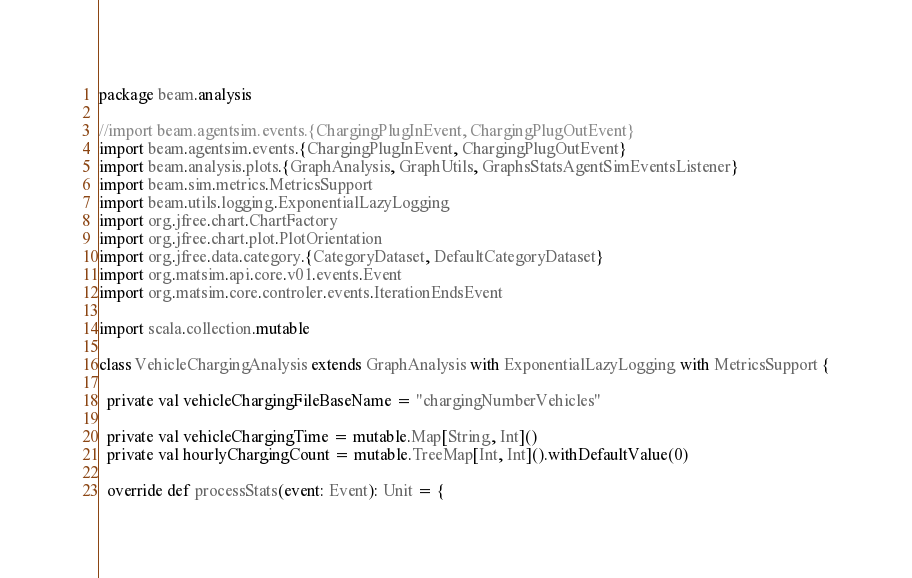Convert code to text. <code><loc_0><loc_0><loc_500><loc_500><_Scala_>package beam.analysis

//import beam.agentsim.events.{ChargingPlugInEvent, ChargingPlugOutEvent}
import beam.agentsim.events.{ChargingPlugInEvent, ChargingPlugOutEvent}
import beam.analysis.plots.{GraphAnalysis, GraphUtils, GraphsStatsAgentSimEventsListener}
import beam.sim.metrics.MetricsSupport
import beam.utils.logging.ExponentialLazyLogging
import org.jfree.chart.ChartFactory
import org.jfree.chart.plot.PlotOrientation
import org.jfree.data.category.{CategoryDataset, DefaultCategoryDataset}
import org.matsim.api.core.v01.events.Event
import org.matsim.core.controler.events.IterationEndsEvent

import scala.collection.mutable

class VehicleChargingAnalysis extends GraphAnalysis with ExponentialLazyLogging with MetricsSupport {

  private val vehicleChargingFileBaseName = "chargingNumberVehicles"

  private val vehicleChargingTime = mutable.Map[String, Int]()
  private val hourlyChargingCount = mutable.TreeMap[Int, Int]().withDefaultValue(0)

  override def processStats(event: Event): Unit = {</code> 